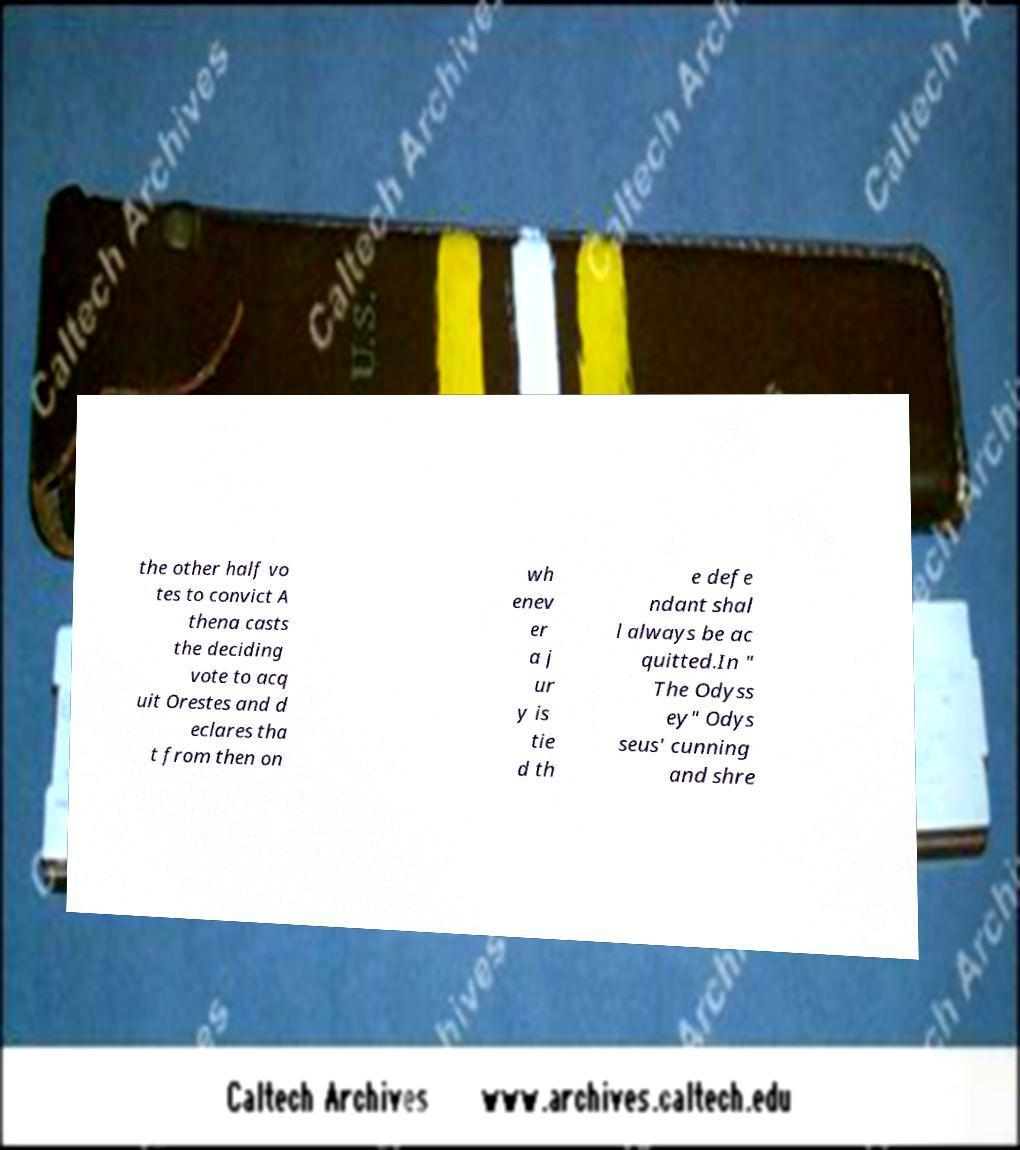There's text embedded in this image that I need extracted. Can you transcribe it verbatim? the other half vo tes to convict A thena casts the deciding vote to acq uit Orestes and d eclares tha t from then on wh enev er a j ur y is tie d th e defe ndant shal l always be ac quitted.In " The Odyss ey" Odys seus' cunning and shre 